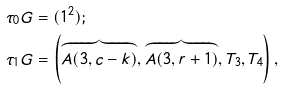<formula> <loc_0><loc_0><loc_500><loc_500>\tau _ { 0 } { G } & = ( 1 ^ { 2 } ) ; \\ \tau _ { 1 } { G } & = \left ( \overbrace { A ( 3 , c - k ) } , \overbrace { A ( 3 , r + 1 ) } , T _ { 3 } , T _ { 4 } \right ) ,</formula> 